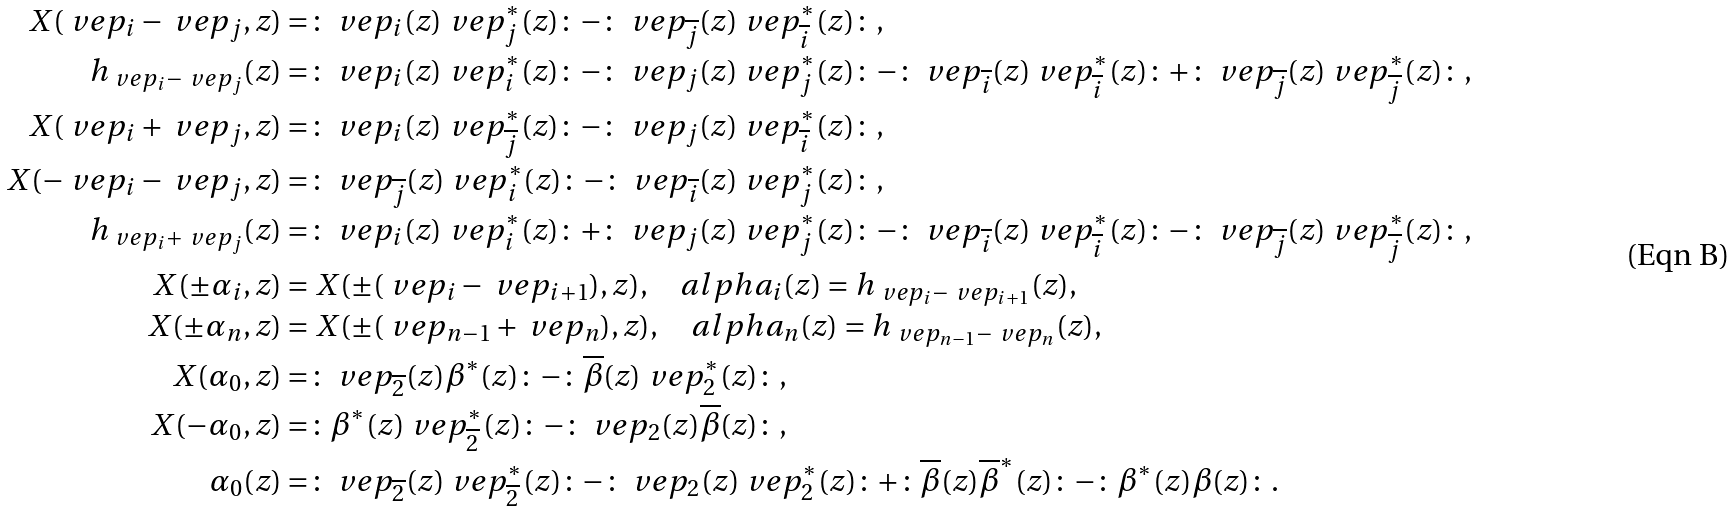<formula> <loc_0><loc_0><loc_500><loc_500>X ( \ v e p _ { i } - \ v e p _ { j } , z ) & = \colon \ v e p _ { i } ( z ) \ v e p _ { j } ^ { * } ( z ) \colon - \colon \ v e p _ { \overline { j } } ( z ) \ v e p _ { \overline { i } } ^ { * } ( z ) \colon , \\ h _ { \ v e p _ { i } - \ v e p _ { j } } ( z ) & = \colon \ v e p _ { i } ( z ) \ v e p _ { i } ^ { * } ( z ) \colon - \colon \ v e p _ { j } ( z ) \ v e p _ { j } ^ { * } ( z ) \colon - \colon \ v e p _ { \overline { i } } ( z ) \ v e p _ { \overline { i } } ^ { * } ( z ) \colon + \colon \ v e p _ { \overline { j } } ( z ) \ v e p _ { \overline { j } } ^ { * } ( z ) \colon , \\ X ( \ v e p _ { i } + \ v e p _ { j } , z ) & = \colon \ v e p _ { i } ( z ) \ v e p _ { \overline { j } } ^ { * } ( z ) \colon - \colon \ v e p _ { j } ( z ) \ v e p _ { \overline { i } } ^ { * } ( z ) \colon , \\ X ( - \ v e p _ { i } - \ v e p _ { j } , z ) & = \colon \ v e p _ { \overline { j } } ( z ) \ v e p _ { i } ^ { * } ( z ) \colon - \colon \ v e p _ { \overline { i } } ( z ) \ v e p _ { j } ^ { * } ( z ) \colon , \\ h _ { \ v e p _ { i } + \ v e p _ { j } } ( z ) & = \colon \ v e p _ { i } ( z ) \ v e p _ { i } ^ { * } ( z ) \colon + \colon \ v e p _ { j } ( z ) \ v e p _ { j } ^ { * } ( z ) \colon - \colon \ v e p _ { \overline { i } } ( z ) \ v e p _ { \overline { i } } ^ { * } ( z ) \colon - \colon \ v e p _ { \overline { j } } ( z ) \ v e p _ { \overline { j } } ^ { * } ( z ) \colon , \\ X ( \pm \alpha _ { i } , z ) & = X ( \pm ( \ v e p _ { i } - \ v e p _ { i + 1 } ) , z ) , \quad a l p h a _ { i } ( z ) = h _ { \ v e p _ { i } - \ v e p _ { i + 1 } } ( z ) , \\ X ( \pm \alpha _ { n } , z ) & = X ( \pm ( \ v e p _ { n - 1 } + \ v e p _ { n } ) , z ) , \quad a l p h a _ { n } ( z ) = h _ { \ v e p _ { n - 1 } - \ v e p _ { n } } ( z ) , \\ X ( \alpha _ { 0 } , z ) & = \colon \ v e p _ { \overline { 2 } } ( z ) \beta ^ { * } ( z ) \colon - \colon \overline { \beta } ( z ) \ v e p _ { 2 } ^ { * } ( z ) \colon , \\ X ( - \alpha _ { 0 } , z ) & = \colon \beta ^ { * } ( z ) \ v e p _ { \overline { 2 } } ^ { * } ( z ) \colon - \colon \ v e p _ { 2 } ( z ) \overline { \beta } ( z ) \colon , \\ \alpha _ { 0 } ( z ) & = \colon \ v e p _ { \overline { 2 } } ( z ) \ v e p _ { \overline { 2 } } ^ { * } ( z ) \colon - \colon \ v e p _ { 2 } ( z ) \ v e p _ { 2 } ^ { * } ( z ) \colon + \colon \overline { \beta } ( z ) \overline { \beta } ^ { * } ( z ) \colon - \colon { \beta } ^ { * } ( z ) { \beta } ( z ) \colon .</formula> 